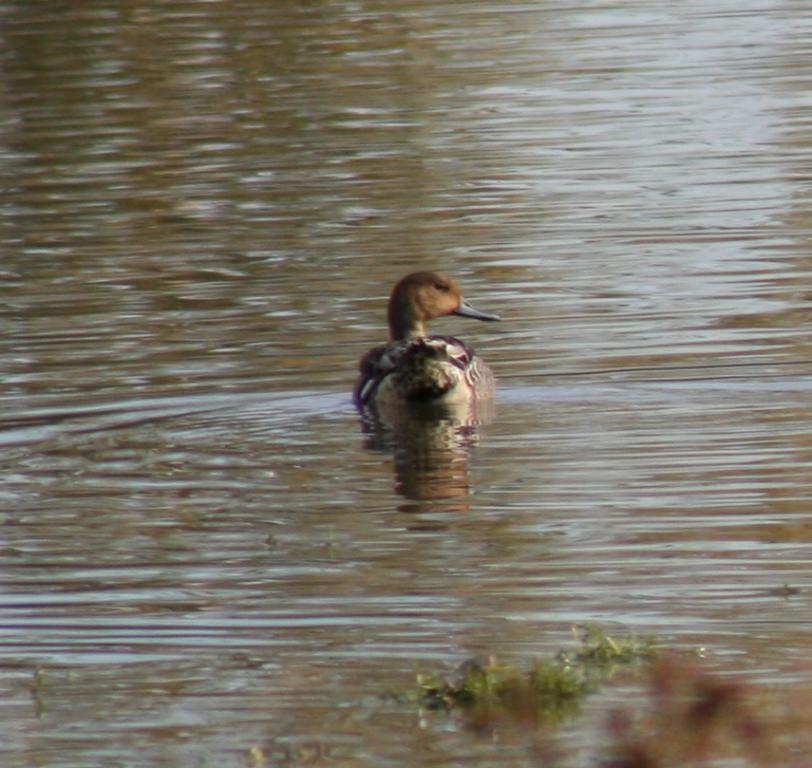What is the main subject of the image? There is a bird in the water. Where is the bird located in the image? The bird is in the center of the image. What else can be seen floating on the water in the image? There are leaves floating on the water in the image. How many balls can be seen in the image? There are no balls present in the image. Is there a bee buzzing around the bird in the image? There is no bee visible in the image; it only features a bird and leaves in the water. 